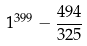Convert formula to latex. <formula><loc_0><loc_0><loc_500><loc_500>1 ^ { 3 9 9 } - \frac { 4 9 4 } { 3 2 5 }</formula> 